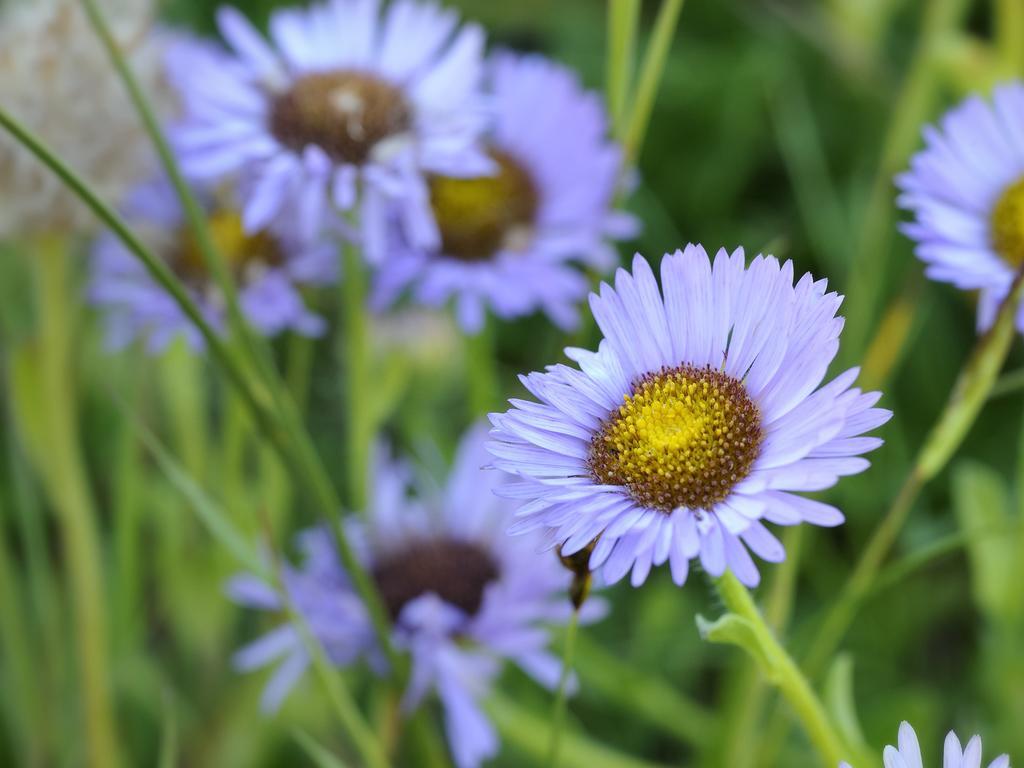Could you give a brief overview of what you see in this image? The picture consists of flowers and plants. The picture is blurred. 